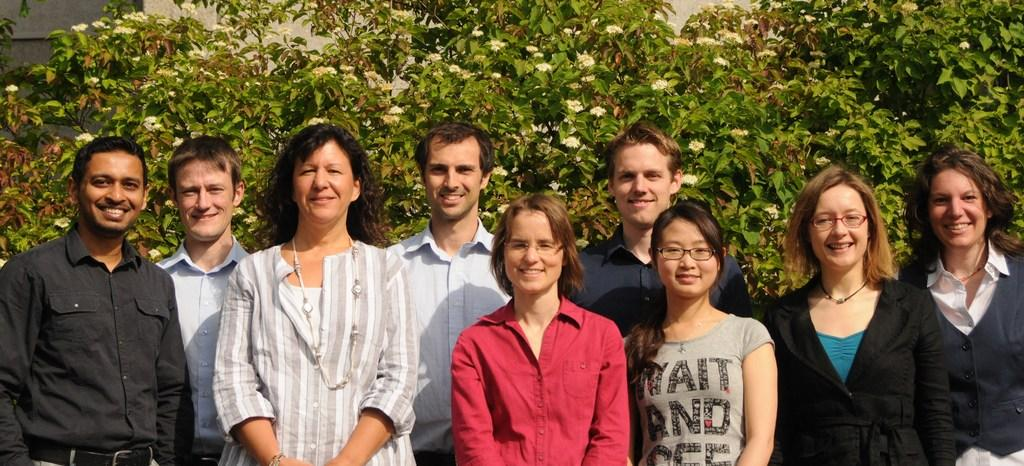What is happening in the image involving a group of people? The people are standing and posing for a photo. What can be seen in the background of the image? There are trees visible in the background of the image. What type of pickle is being held by the giants in the image? There are no giants or pickles present in the image. 